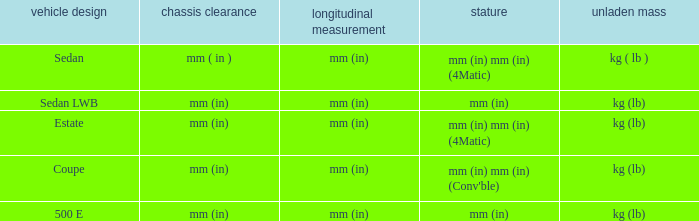What's the length of the model with 500 E body style? Mm (in). 